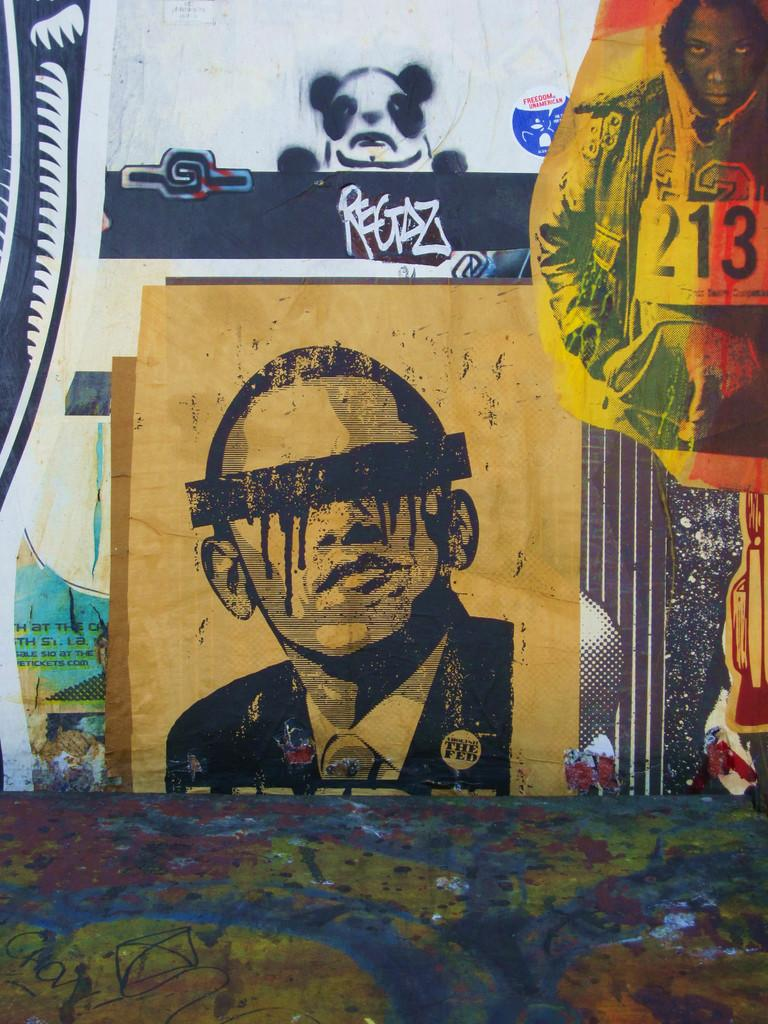<image>
Create a compact narrative representing the image presented. A collection of graffiti art includes a painting of Obama wearing an anti Fed button. 